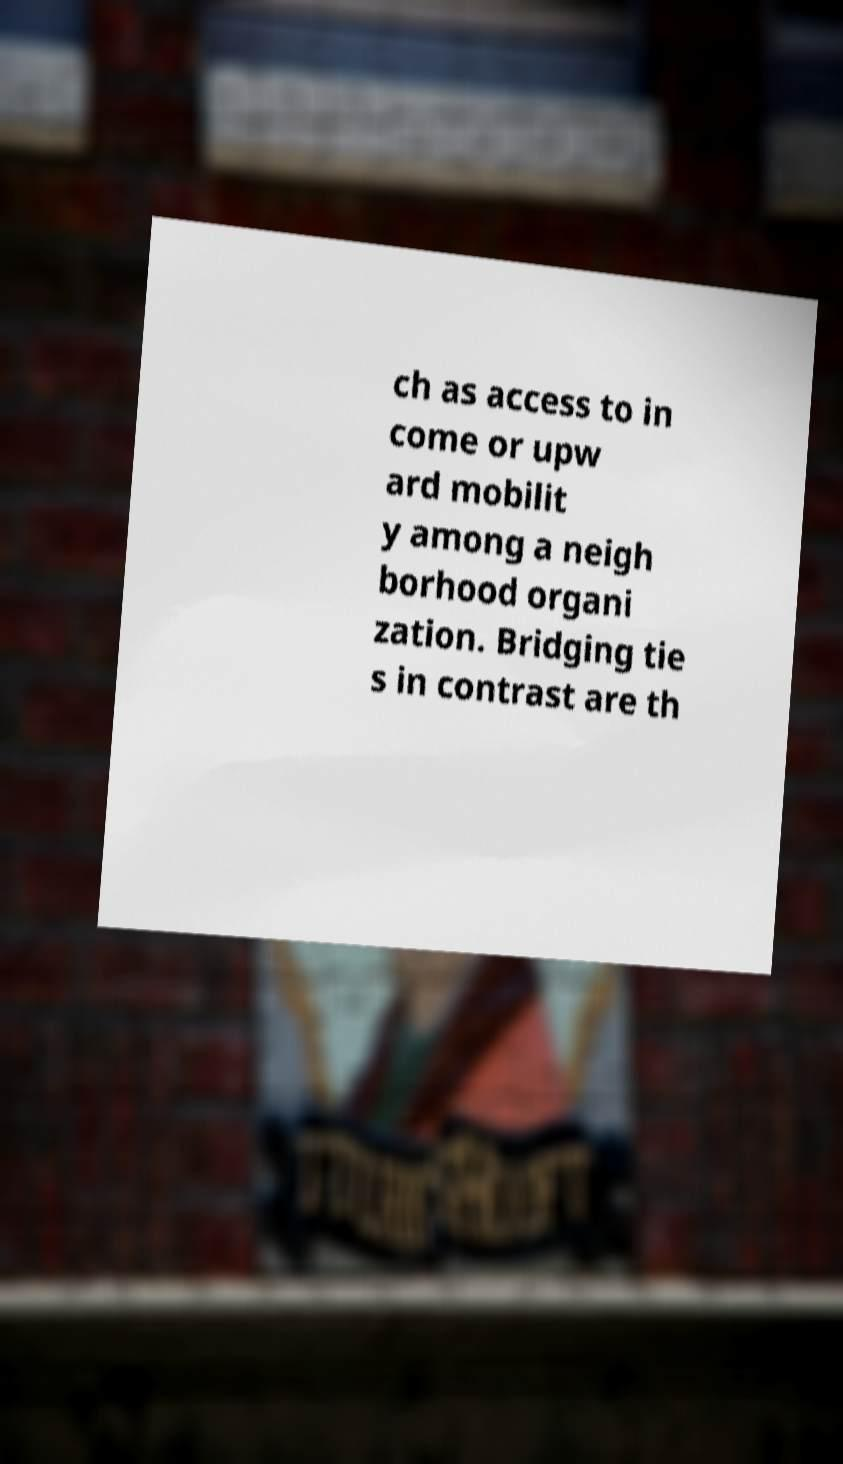Could you extract and type out the text from this image? ch as access to in come or upw ard mobilit y among a neigh borhood organi zation. Bridging tie s in contrast are th 